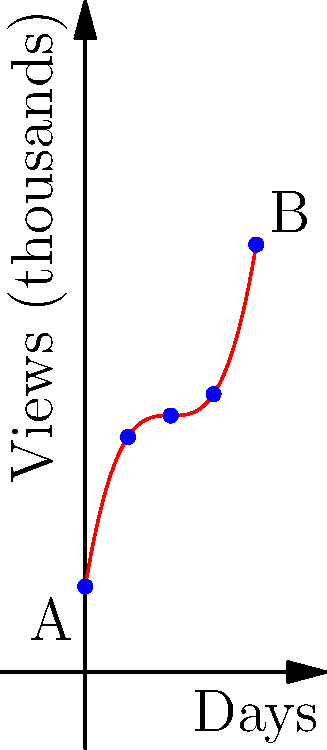A beauty vlogger's daily view count (in thousands) over a 4-day period can be modeled by the function $f(x) = 0.5x^3 - 3x^2 + 6x + 2$, where $x$ represents the number of days since the start of the period. Calculate the total number of views the vlogger received during these 4 days. To find the total number of views over the 4-day period, we need to calculate the area under the curve from $x=0$ to $x=4$. This can be done using definite integration:

1) The integral of $f(x)$ from 0 to 4 is:
   $$\int_0^4 (0.5x^3 - 3x^2 + 6x + 2) dx$$

2) Integrate each term:
   $$[\frac{0.5x^4}{4} - x^3 + 3x^2 + 2x]_0^4$$

3) Evaluate at the upper and lower bounds:
   $$(\frac{0.5(4^4)}{4} - 4^3 + 3(4^2) + 2(4)) - (\frac{0.5(0^4)}{4} - 0^3 + 3(0^2) + 2(0))$$

4) Simplify:
   $$(32 - 64 + 48 + 8) - (0 - 0 + 0 + 0) = 24$$

5) The result, 24, represents the area under the curve in thousands of views.

6) To get the total number of views, multiply by 1000:
   $24 * 1000 = 24,000$

Therefore, the vlogger received a total of 24,000 views over the 4-day period.
Answer: 24,000 views 